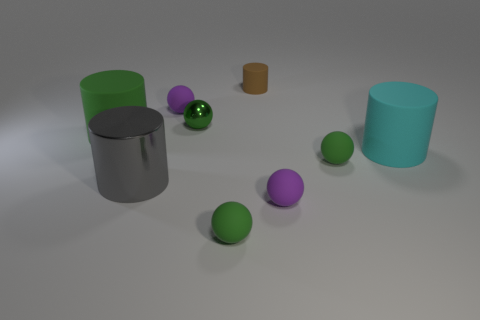Subtract all green balls. How many were subtracted if there are1green balls left? 2 Subtract all gray metallic cylinders. How many cylinders are left? 3 Subtract all blue blocks. How many purple spheres are left? 2 Subtract 1 cylinders. How many cylinders are left? 3 Subtract all purple spheres. How many spheres are left? 3 Subtract all spheres. How many objects are left? 4 Subtract all gray balls. Subtract all blue cylinders. How many balls are left? 5 Add 6 small shiny spheres. How many small shiny spheres exist? 7 Subtract 0 blue cylinders. How many objects are left? 9 Subtract all tiny brown matte cubes. Subtract all metal things. How many objects are left? 7 